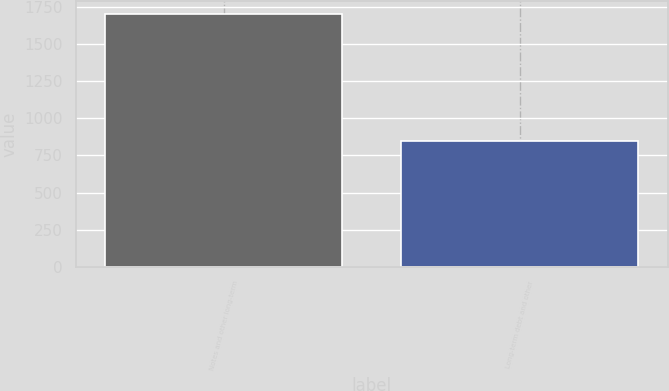Convert chart to OTSL. <chart><loc_0><loc_0><loc_500><loc_500><bar_chart><fcel>Notes and other long-term<fcel>Long-term debt and other<nl><fcel>1702<fcel>848<nl></chart> 